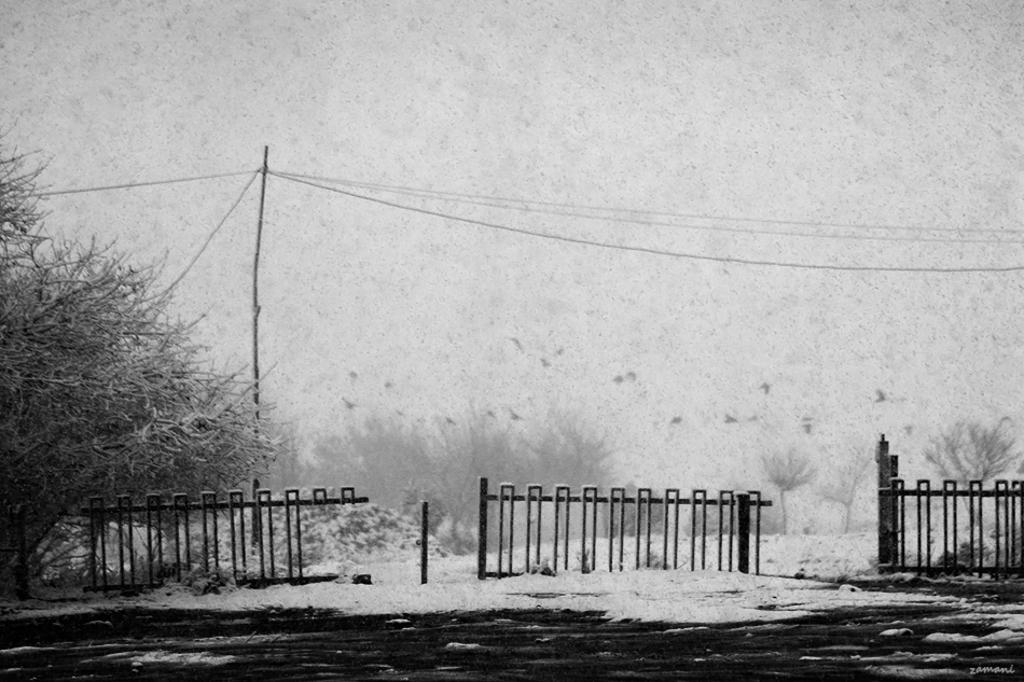What is happening in the image? Snow is falling in the image. What can be seen in the image besides the snow? Plants and trees are visible in the image. How are the plants and trees affected by the snow? The plants and trees are covered with snow. What is the condition of the sky in the image? The sky appears foggy in the image. Can you see a house made of bones in the image? No, there is no house made of bones in the image. 